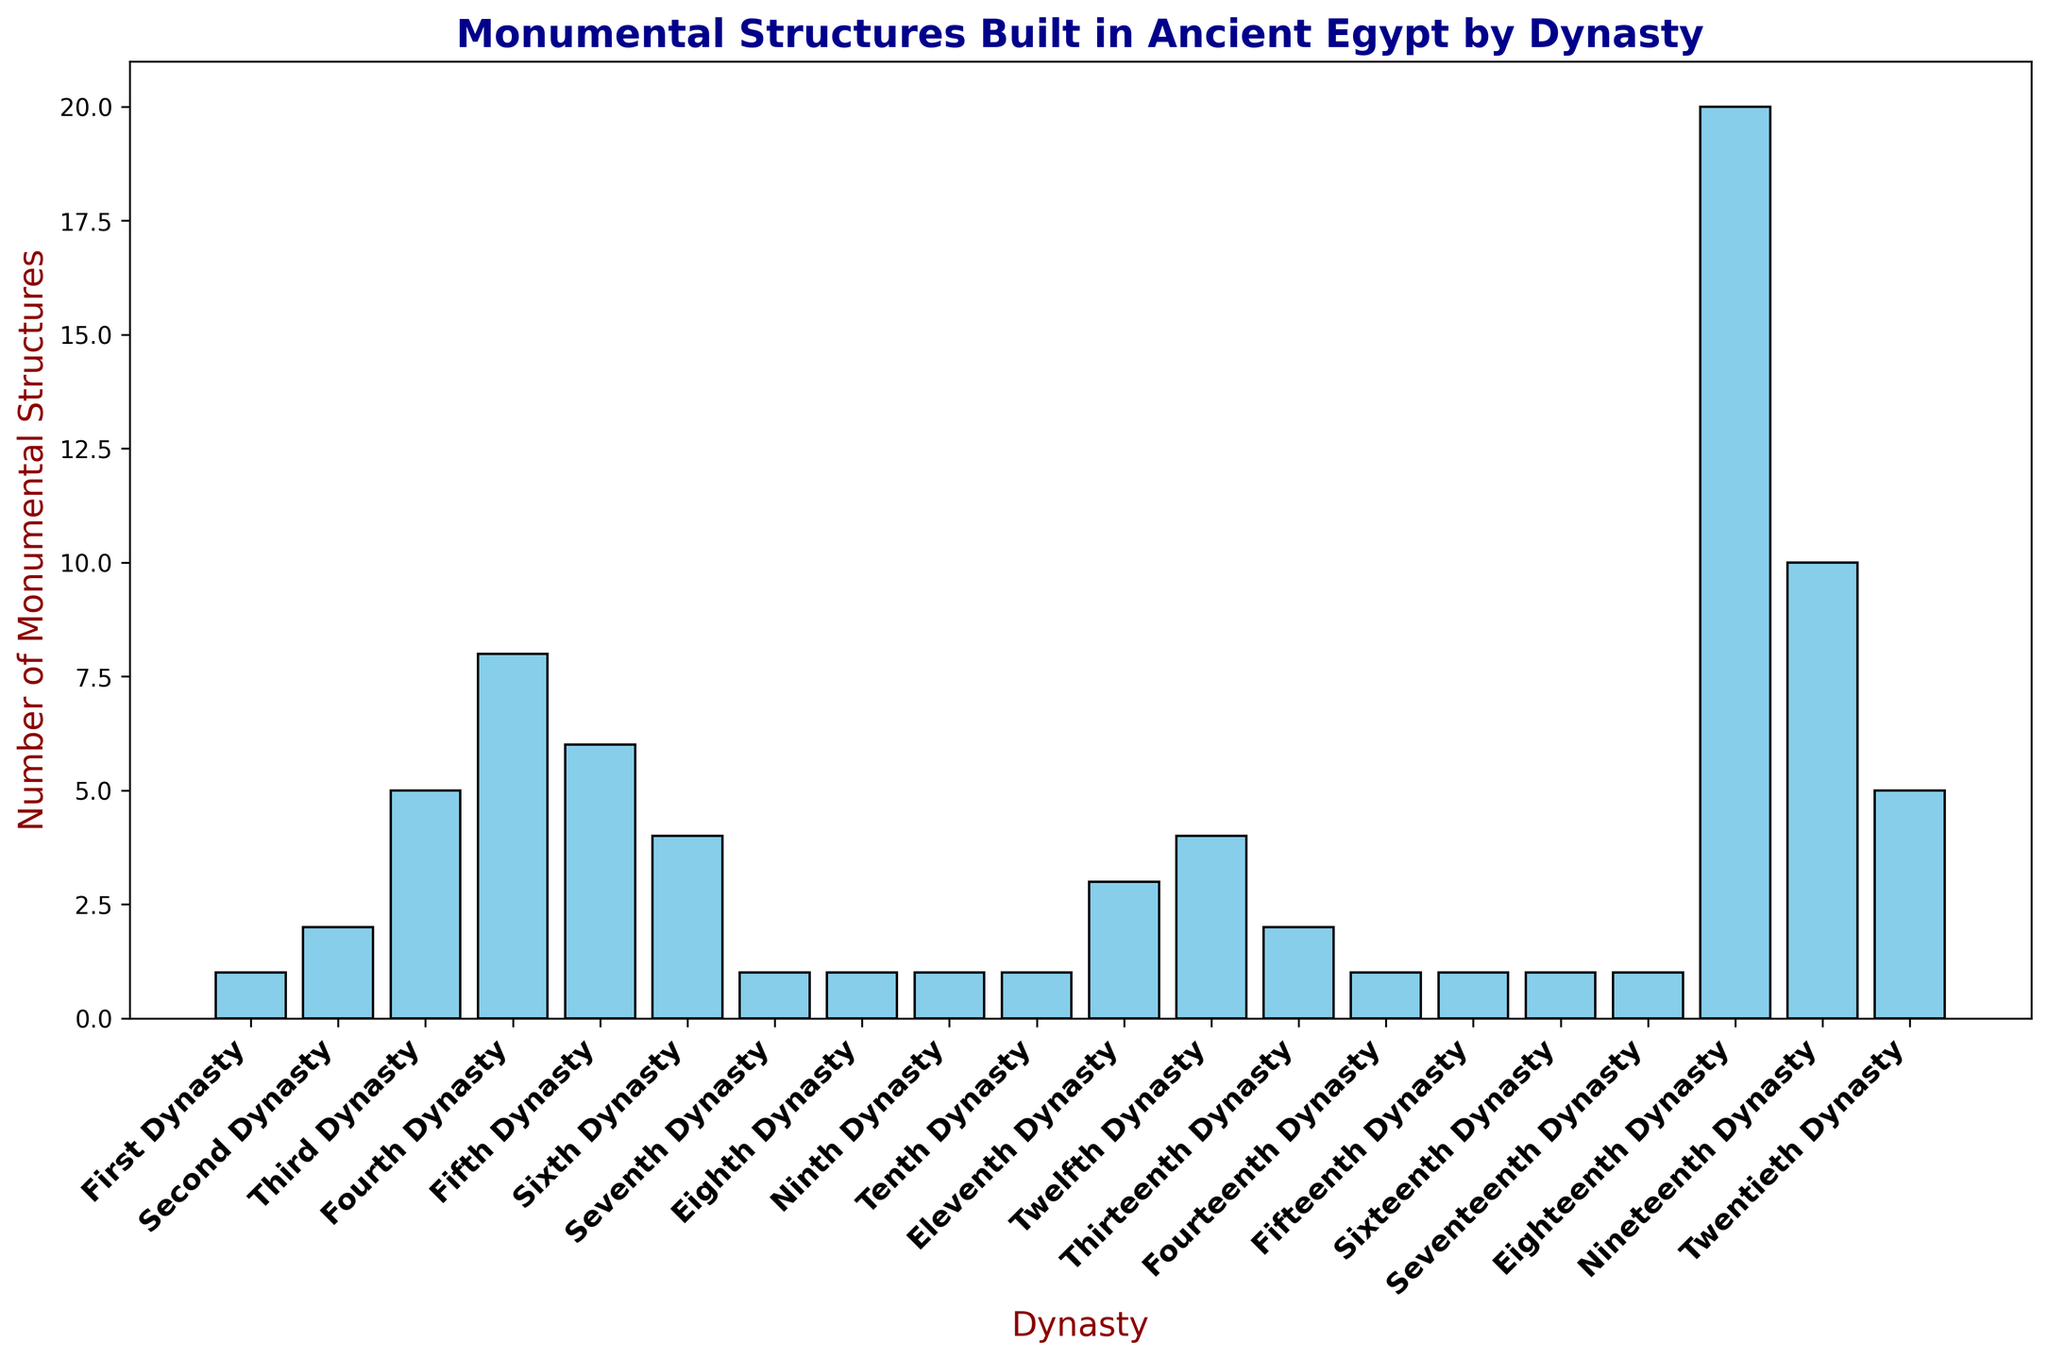Which dynasty built the most monumental structures? To find the dynasty that built the most monumental structures, look for the tallest bar in the bar chart. The Eighteenth Dynasty has the tallest bar with 20 structures.
Answer: Eighteenth Dynasty Which dynasty constructed the fewest monumental structures? Several dynasties have bars of equal short height, indicating they built the fewest monumental structures. These dynasties each built 1 monumental structure.
Answer: First, Seventh, Eighth, Ninth, Tenth, Fourteenth, Fifteenth, Sixteenth, and Seventeenth Dynasties Which two dynasties combined built the highest number of monumental structures? Identify the dynasties with the tallest bars and sum their values. The Eighteenth Dynasty built 20 structures, and the Nineteenth Dynasty built 10 structures. Combined, they built 30 structures.
Answer: Eighteenth and Nineteenth Dynasties How many more monumental structures did the Fourth Dynasty build compared to the Sixth Dynasty? Locate the bars for the Fourth and Sixth Dynasties to compare their heights. The Fourth Dynasty built 8 structures, and the Sixth Dynasty built 4 structures. Subtract the two values: 8 - 4 = 4.
Answer: 4 Which dynasties built exactly 5 monumental structures? Identify the bars that reach up to the value of 5. The Third and Twentieth Dynasties each built 5 monumental structures.
Answer: Third and Twentieth Dynasties How many dynasties built more than 5 monumental structures? Count the bars taller than the value of 5. The Fourth, Fifth, Eighteenth, and Nineteenth Dynasties qualify, resulting in four dynasties.
Answer: 4 Comparing the Number of Monumental Structures: Was the Fifth Dynasty more productive than the Twelfth Dynasty? Compare the heights of the bars for the Fifth and Twelfth Dynasties. The Fifth Dynasty built 6 structures, while the Twelfth built 4 structures. Since 6 > 4, the Fifth Dynasty was more productive.
Answer: Yes What's the average number of monumental structures built by the first five dynasties? Sum the structures for the First, Second, Third, Fourth, and Fifth Dynasties: 1 + 2 + 5 + 8 + 6 = 22. Then, divide by 5: 22 / 5 = 4.4.
Answer: 4.4 What's the total number of monumental structures built by the Eleventh and Twelfth Dynasties combined? Sum the structures built by the Eleventh and Twelfth Dynasties. The Eleventh Dynasty built 3, and the Twelfth built 4. So, 3 + 4 = 7.
Answer: 7 Which dynasties built exactly 1 structure during their reign? Identify and list the dynasties with bars reaching the value of 1.
Answer: First, Seventh, Eighth, Ninth, Tenth, Fourteenth, Fifteenth, Sixteenth, and Seventeenth Dynasties 